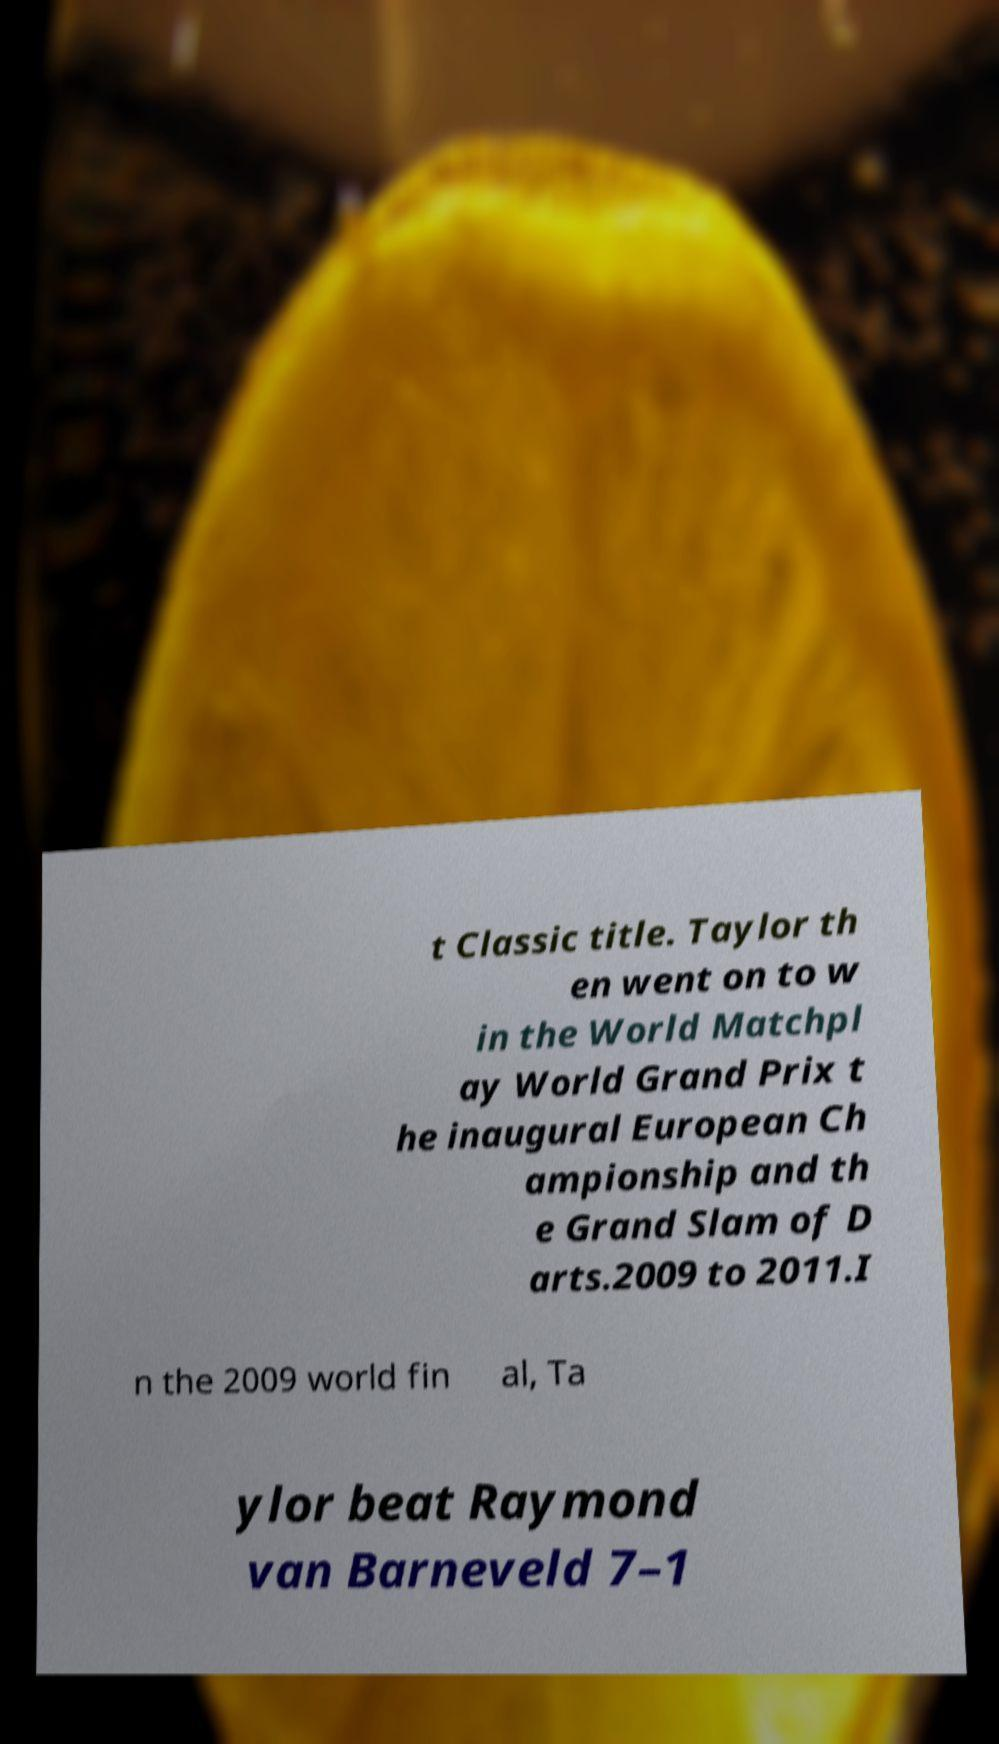Could you extract and type out the text from this image? t Classic title. Taylor th en went on to w in the World Matchpl ay World Grand Prix t he inaugural European Ch ampionship and th e Grand Slam of D arts.2009 to 2011.I n the 2009 world fin al, Ta ylor beat Raymond van Barneveld 7–1 